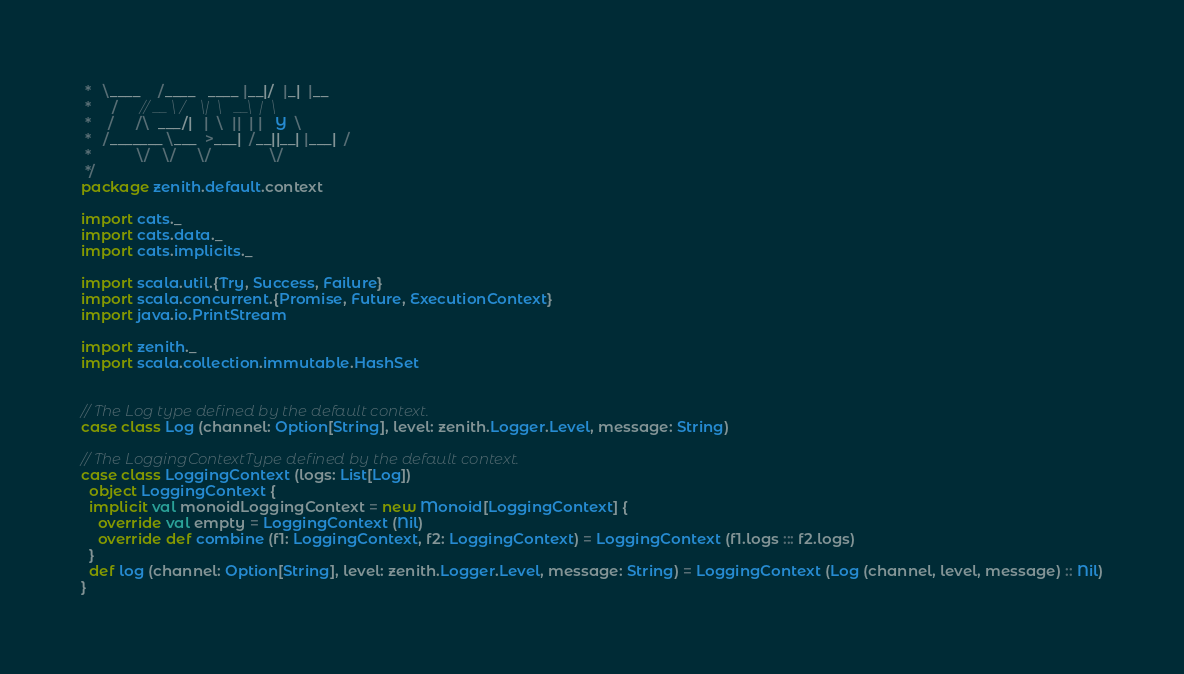Convert code to text. <code><loc_0><loc_0><loc_500><loc_500><_Scala_> *   \____    /____   ____ |__|/  |_|  |__
 *     /     // __ \ /    \|  \   __\  |  \
 *    /     /\  ___/|   |  \  ||  | |   Y  \
 *   /_______ \___  >___|  /__||__| |___|  /
 *           \/   \/     \/              \/
 */
package zenith.default.context

import cats._
import cats.data._
import cats.implicits._

import scala.util.{Try, Success, Failure}
import scala.concurrent.{Promise, Future, ExecutionContext}
import java.io.PrintStream

import zenith._
import scala.collection.immutable.HashSet


// The Log type defined by the default context.
case class Log (channel: Option[String], level: zenith.Logger.Level, message: String)

// The LoggingContextType defined by the default context.
case class LoggingContext (logs: List[Log])
  object LoggingContext {
  implicit val monoidLoggingContext = new Monoid[LoggingContext] {
    override val empty = LoggingContext (Nil)
    override def combine (f1: LoggingContext, f2: LoggingContext) = LoggingContext (f1.logs ::: f2.logs)
  }
  def log (channel: Option[String], level: zenith.Logger.Level, message: String) = LoggingContext (Log (channel, level, message) :: Nil)
}

</code> 